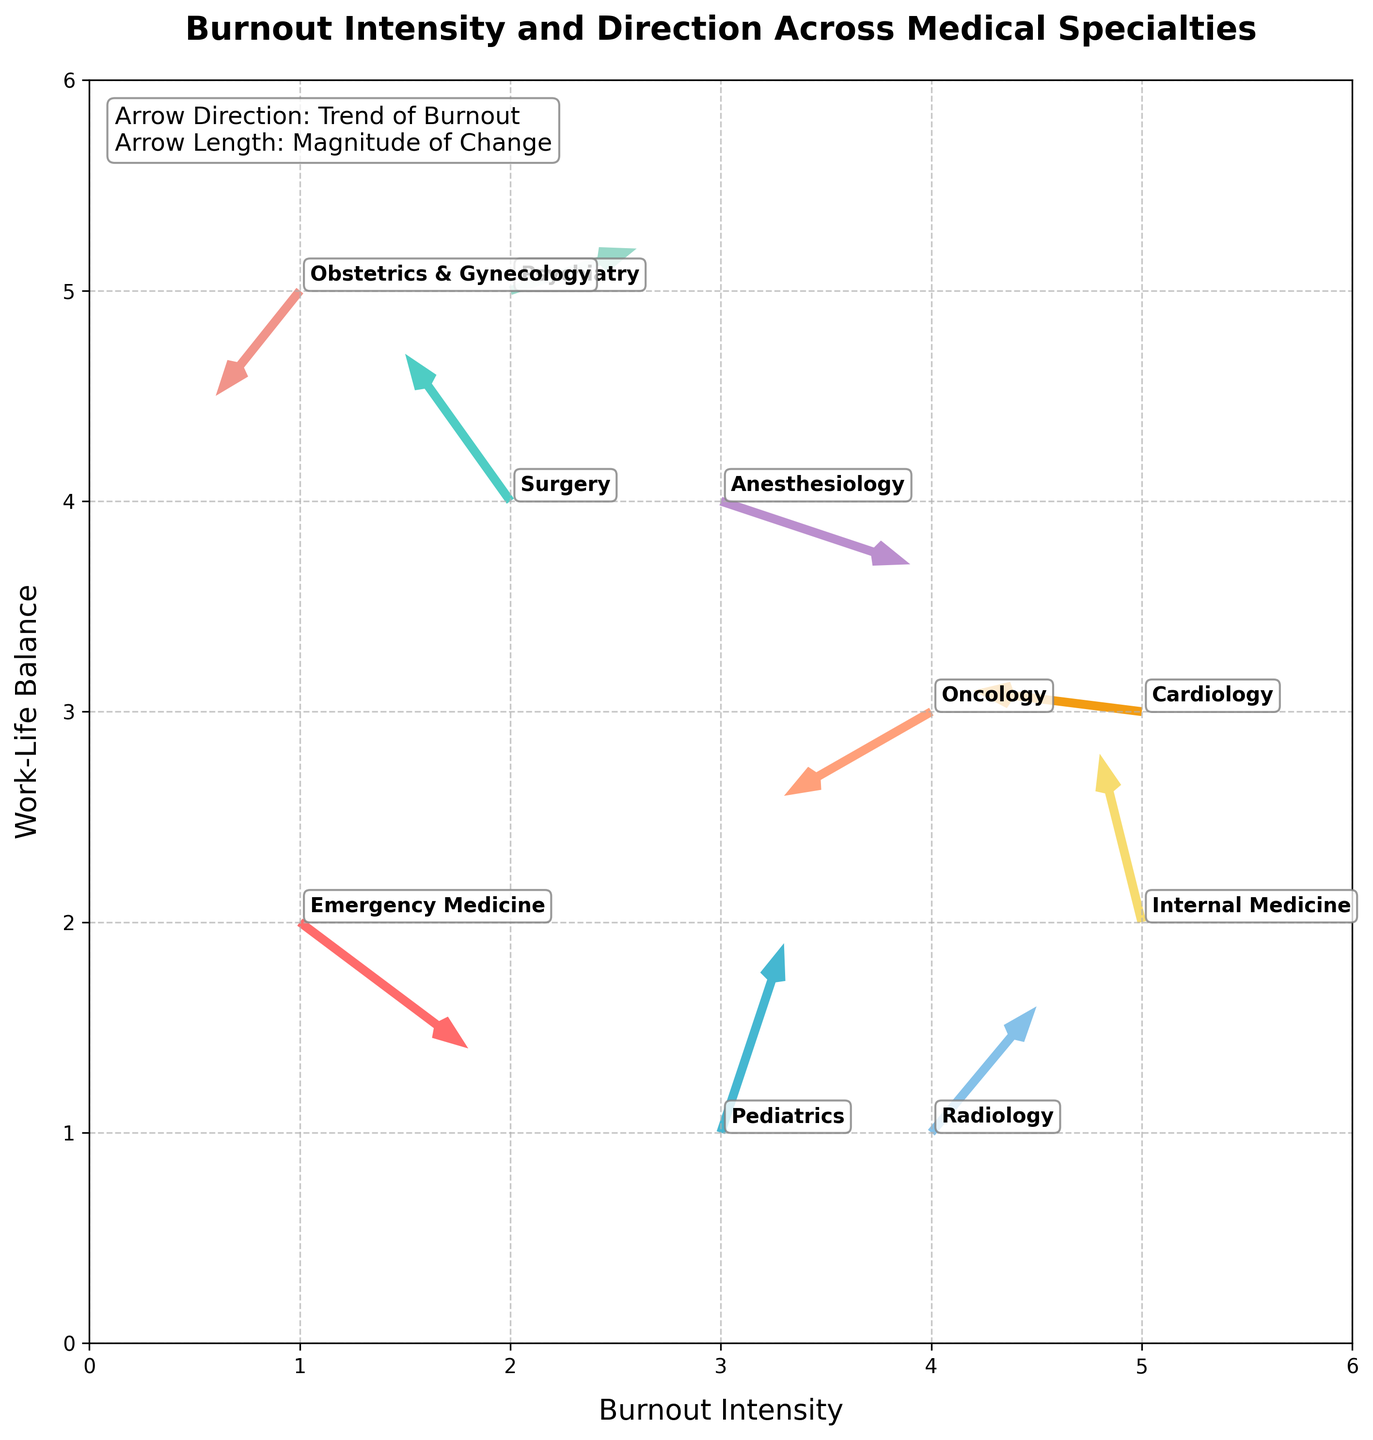How many medical specialties are represented in the quiver plot? Count the number of unique specialties mentioned in the plot.
Answer: 10 Which specialty has the highest burnout intensity? Look for the arrow originating from the farthest right position on the x-axis. Oncology has an x-coordinate of 4, which is the highest.
Answer: Oncology In which direction is burnout intensity decreasing the most? Observe the arrows pointing most steeply to the left. Cardiology's arrow points significantly to the left.
Answer: Cardiology How does the burnout trend in Pediatrics compare to that in Surgery? Compare the directions and lengths of the arrows originating from Pediatrics and Surgery. Pediatrics has a positive u and v, indicating increased intensity and better balance. Surgery has a negative u and positive v, indicating decreased intensity and better balance.
Answer: Pediatrics shows improvement in both intensity and balance, Surgery shows increasing balance but decreasing intensity Which specialty shows the most balanced work-life trend despite burnout intensity? Look for the arrow with the largest positive v-component. Pediatrics has a large positive v-component.
Answer: Pediatrics What are the colors used to represent the specialties? List the colors visually represented by the arrows.
Answer: Red, turquoise, blue, light orange, green, yellow, light purple, pink, light blue, and orange Which quadrant contains most of the starting points of the arrows? Count the starting points of the arrows within different quadrants. Most arrows originate from the first quadrant (positive x and y).
Answer: First quadrant Which specialty shows an upward trend in both burnout intensity and work-life balance? Look for arrows with both positive u and positive v-components. Pediatrics and Radiology both show upward trends in burnout intensity and balance.
Answer: Pediatrics and Radiology How does the burnout direction for Internal Medicine compare to Psychiatry? Compare the direction vectors (u, v) for both specialties. Internal Medicine has negative u and positive v, indicating slight decrease in intensity but better balance. Psychiatry has positive u and v, indicating increase in both.
Answer: Internal Medicine shows slightly decreased intensity and better balance, Psychiatry shows increase in both What logical operations can you perform to find the specialty with the least decrease in work-life balance? Compare the v-component of vectors for all specialties to find the least negative or most positive v. Obstetrics & Gynecology has a negative v of -0.5, but it is close to zero compared to other specialties heading downward.
Answer: Obstetrics & Gynecology 